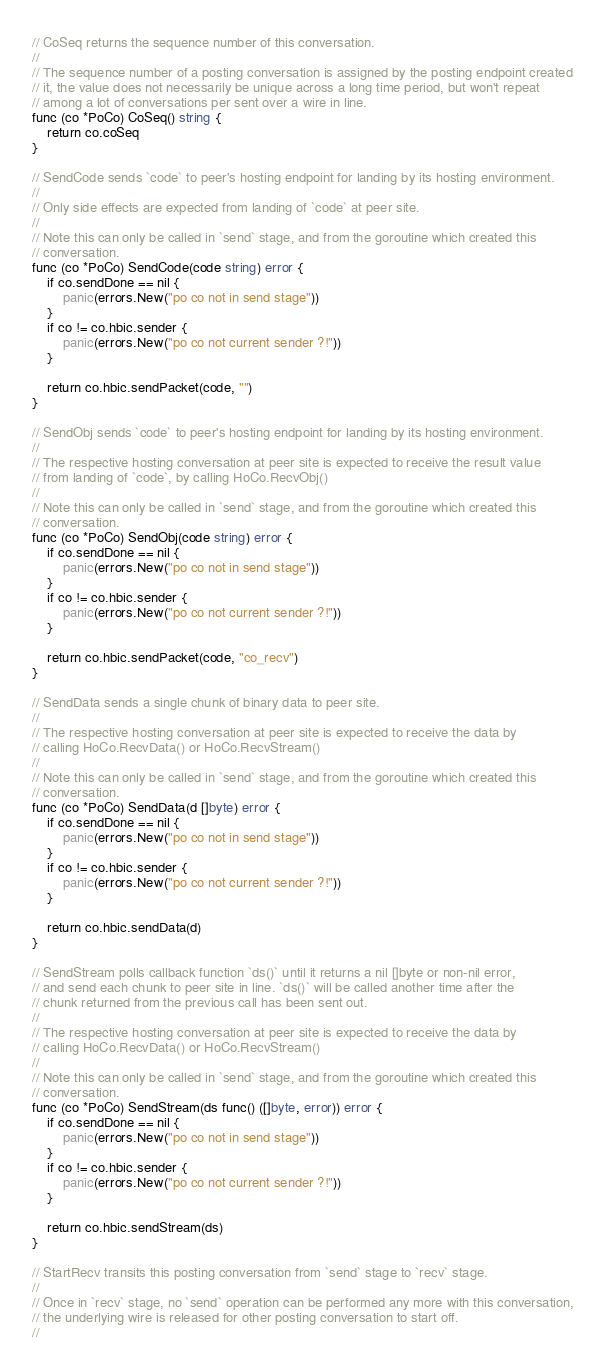<code> <loc_0><loc_0><loc_500><loc_500><_Go_>// CoSeq returns the sequence number of this conversation.
//
// The sequence number of a posting conversation is assigned by the posting endpoint created
// it, the value does not necessarily be unique across a long time period, but won't repeat
// among a lot of conversations per sent over a wire in line.
func (co *PoCo) CoSeq() string {
	return co.coSeq
}

// SendCode sends `code` to peer's hosting endpoint for landing by its hosting environment.
//
// Only side effects are expected from landing of `code` at peer site.
//
// Note this can only be called in `send` stage, and from the goroutine which created this
// conversation.
func (co *PoCo) SendCode(code string) error {
	if co.sendDone == nil {
		panic(errors.New("po co not in send stage"))
	}
	if co != co.hbic.sender {
		panic(errors.New("po co not current sender ?!"))
	}

	return co.hbic.sendPacket(code, "")
}

// SendObj sends `code` to peer's hosting endpoint for landing by its hosting environment.
//
// The respective hosting conversation at peer site is expected to receive the result value
// from landing of `code`, by calling HoCo.RecvObj()
//
// Note this can only be called in `send` stage, and from the goroutine which created this
// conversation.
func (co *PoCo) SendObj(code string) error {
	if co.sendDone == nil {
		panic(errors.New("po co not in send stage"))
	}
	if co != co.hbic.sender {
		panic(errors.New("po co not current sender ?!"))
	}

	return co.hbic.sendPacket(code, "co_recv")
}

// SendData sends a single chunk of binary data to peer site.
//
// The respective hosting conversation at peer site is expected to receive the data by
// calling HoCo.RecvData() or HoCo.RecvStream()
//
// Note this can only be called in `send` stage, and from the goroutine which created this
// conversation.
func (co *PoCo) SendData(d []byte) error {
	if co.sendDone == nil {
		panic(errors.New("po co not in send stage"))
	}
	if co != co.hbic.sender {
		panic(errors.New("po co not current sender ?!"))
	}

	return co.hbic.sendData(d)
}

// SendStream polls callback function `ds()` until it returns a nil []byte or non-nil error,
// and send each chunk to peer site in line. `ds()` will be called another time after the
// chunk returned from the previous call has been sent out.
//
// The respective hosting conversation at peer site is expected to receive the data by
// calling HoCo.RecvData() or HoCo.RecvStream()
//
// Note this can only be called in `send` stage, and from the goroutine which created this
// conversation.
func (co *PoCo) SendStream(ds func() ([]byte, error)) error {
	if co.sendDone == nil {
		panic(errors.New("po co not in send stage"))
	}
	if co != co.hbic.sender {
		panic(errors.New("po co not current sender ?!"))
	}

	return co.hbic.sendStream(ds)
}

// StartRecv transits this posting conversation from `send` stage to `recv` stage.
//
// Once in `recv` stage, no `send` operation can be performed any more with this conversation,
// the underlying wire is released for other posting conversation to start off.
//</code> 